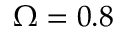<formula> <loc_0><loc_0><loc_500><loc_500>\Omega = 0 . 8</formula> 